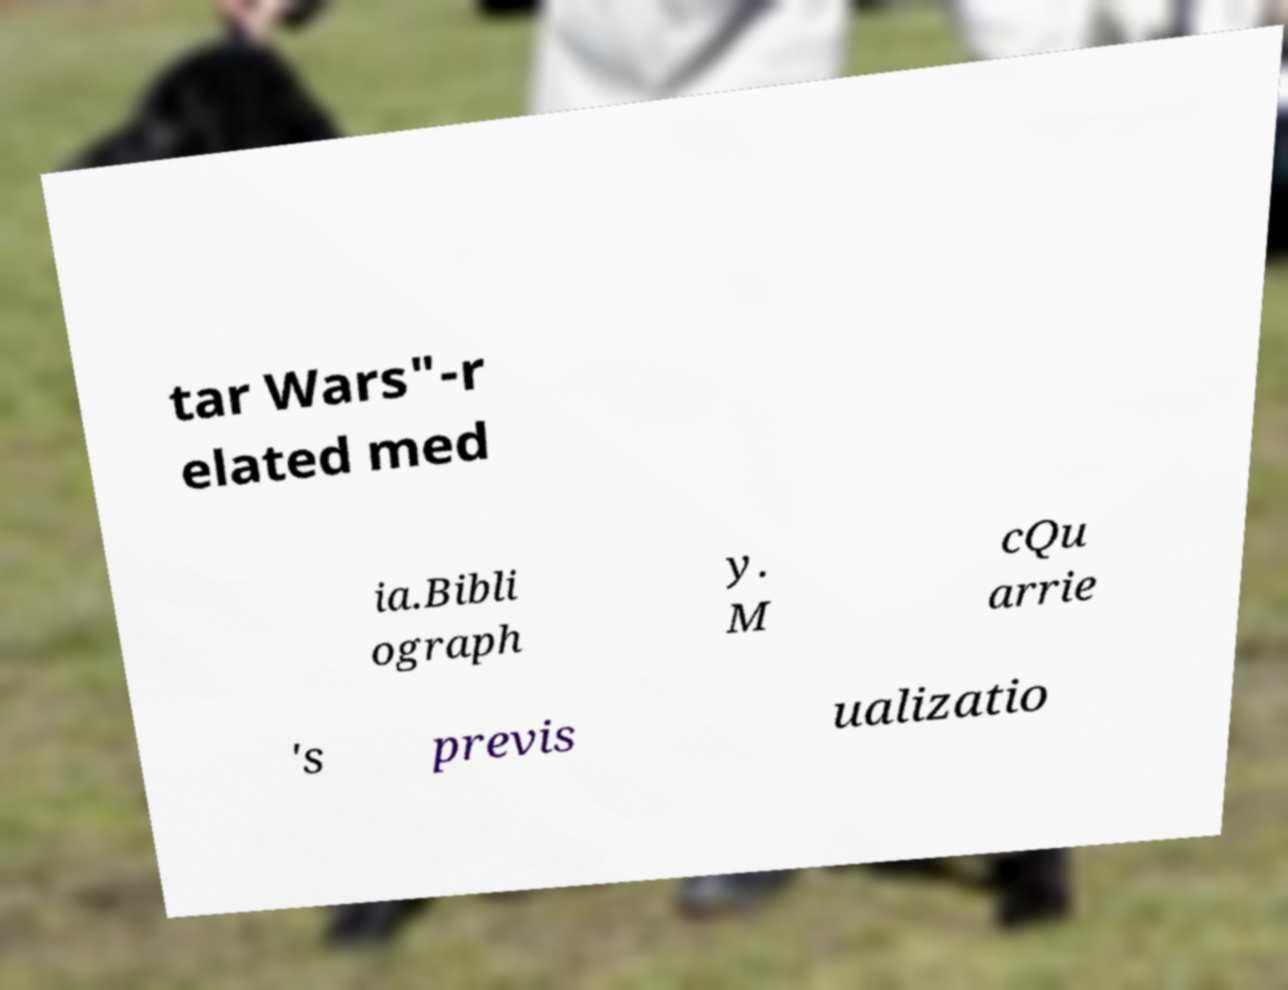I need the written content from this picture converted into text. Can you do that? tar Wars"-r elated med ia.Bibli ograph y. M cQu arrie 's previs ualizatio 